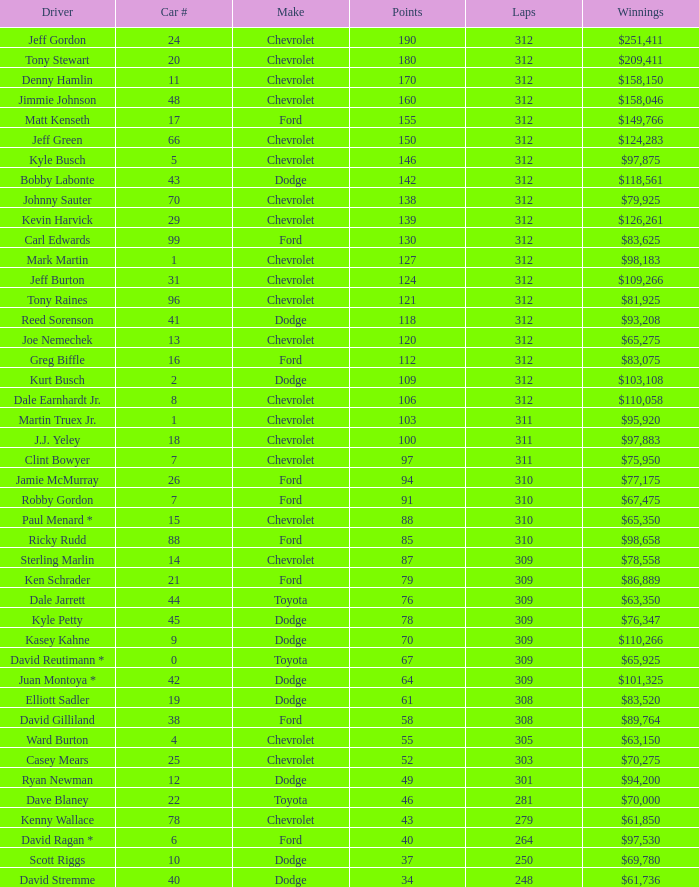What is the sum of laps that has a car number of larger than 1, is a ford, and has 155 points? 312.0. 